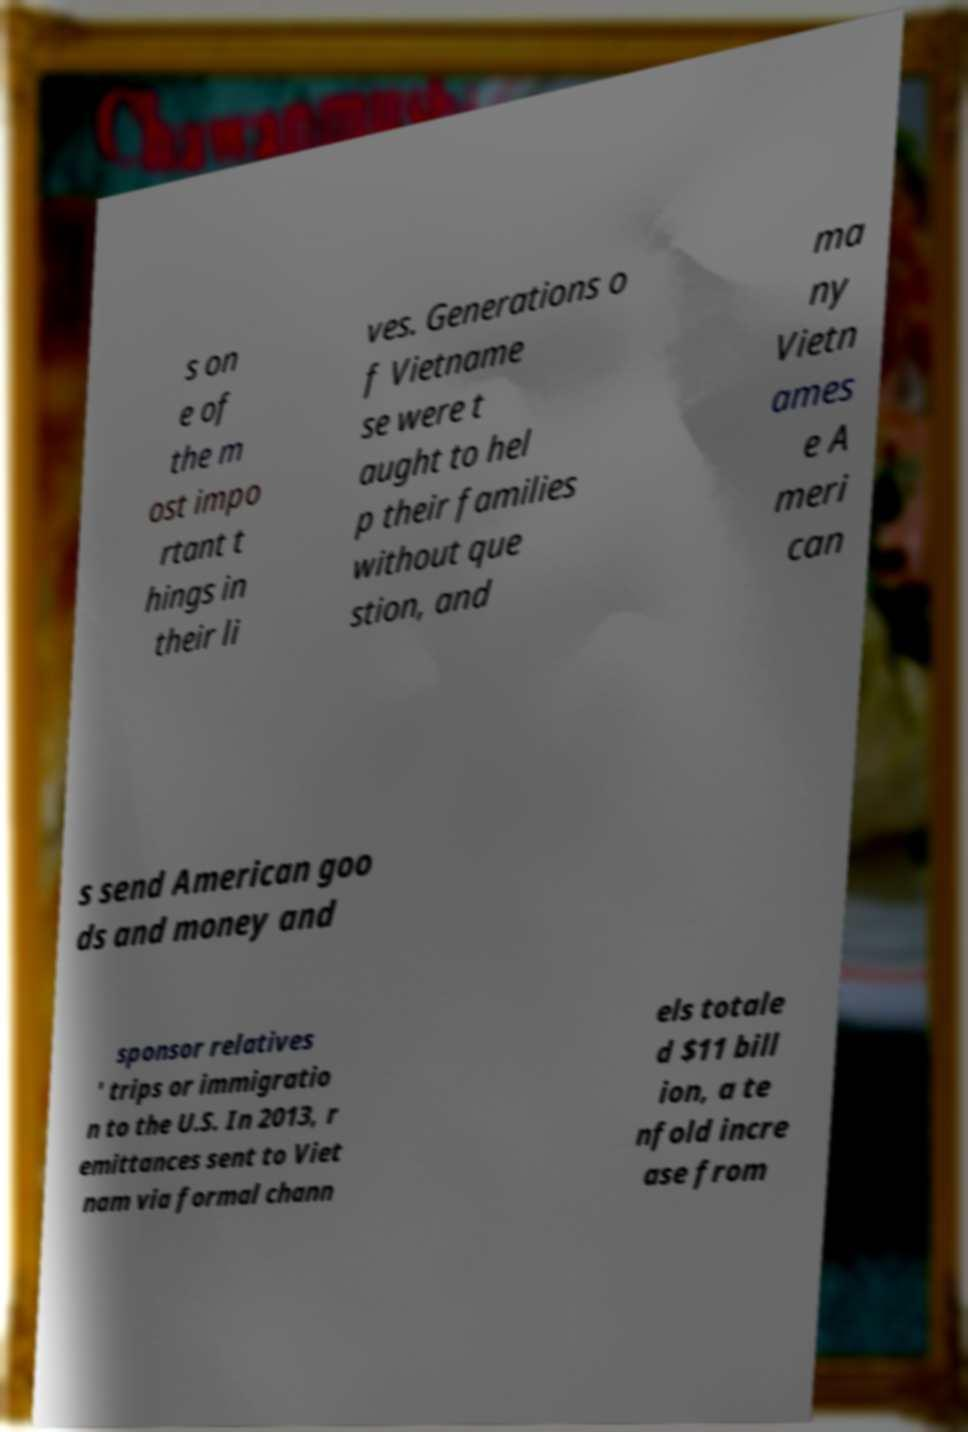Could you extract and type out the text from this image? s on e of the m ost impo rtant t hings in their li ves. Generations o f Vietname se were t aught to hel p their families without que stion, and ma ny Vietn ames e A meri can s send American goo ds and money and sponsor relatives ' trips or immigratio n to the U.S. In 2013, r emittances sent to Viet nam via formal chann els totale d $11 bill ion, a te nfold incre ase from 